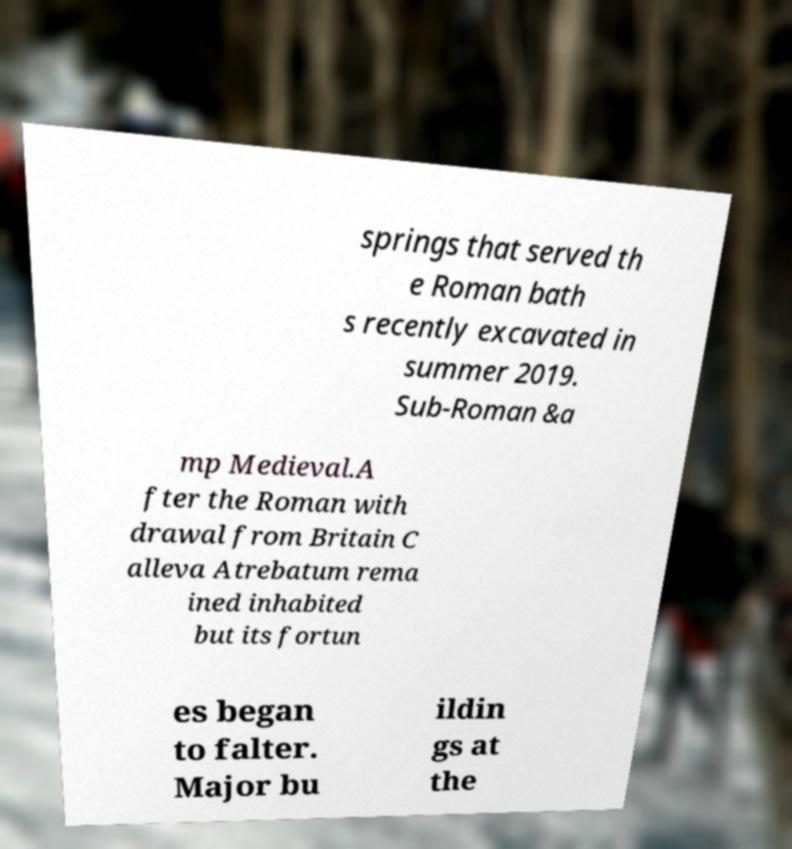Please read and relay the text visible in this image. What does it say? springs that served th e Roman bath s recently excavated in summer 2019. Sub-Roman &a mp Medieval.A fter the Roman with drawal from Britain C alleva Atrebatum rema ined inhabited but its fortun es began to falter. Major bu ildin gs at the 